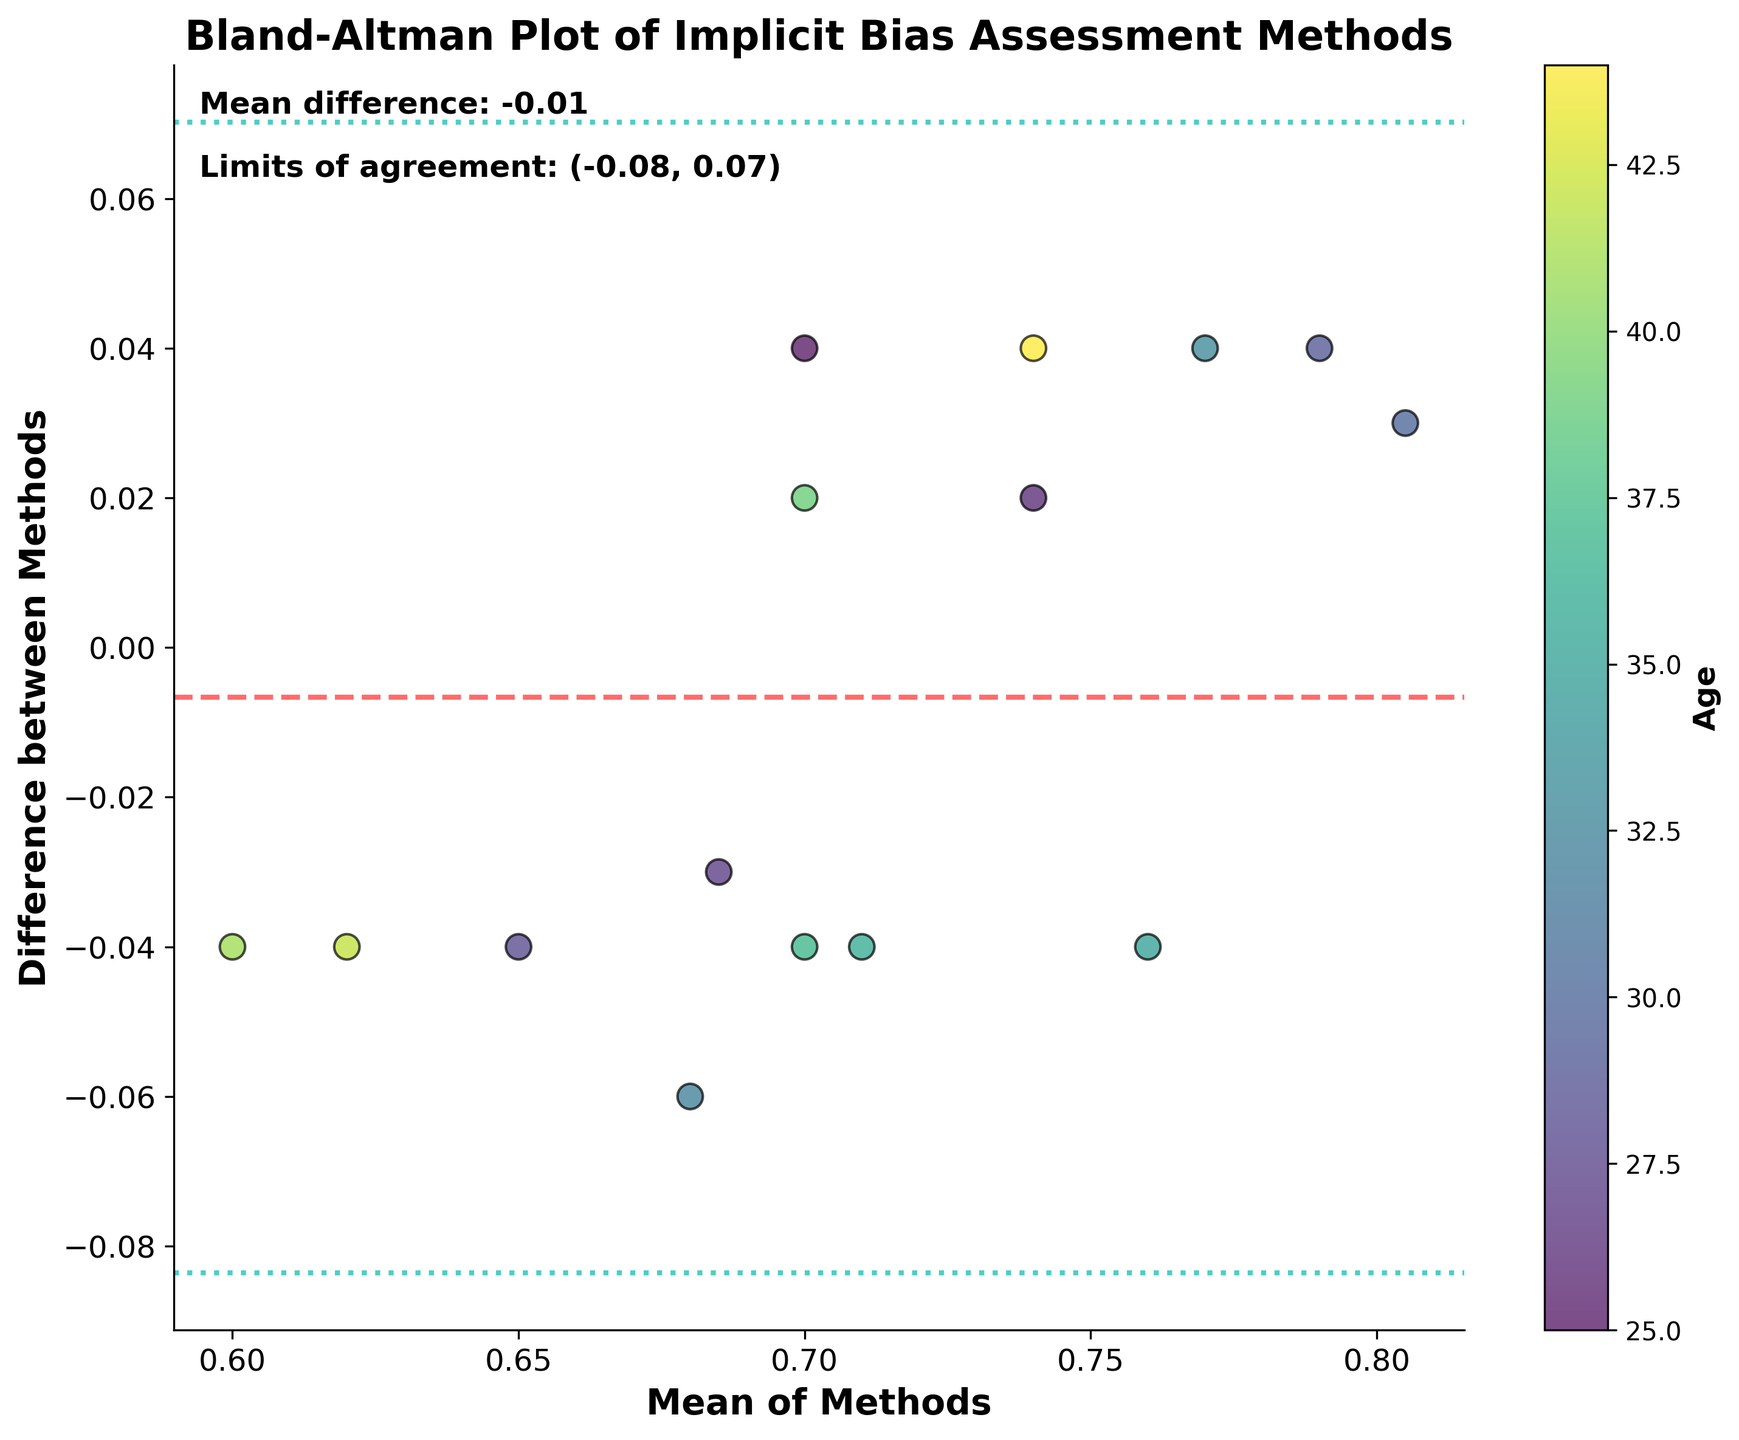What is the title of the plot? The plot's title is found at the top of the figure. It reads "Bland-Altman Plot of Implicit Bias Assessment Methods."
Answer: Bland-Altman Plot of Implicit Bias Assessment Methods How are the dots colored, and what does the color represent? The dots are colored in shades of green to yellow, representing different ages of the participants according to the color bar on the side.
Answer: Different ages What are the axes labeled? The axes labels are written next to each axis. The x-axis is labeled "Mean of Methods," and the y-axis is labeled "Difference between Methods."
Answer: Mean of Methods (x-axis), Difference between Methods (y-axis) What's the mean difference between the two methods? The mean difference is provided in the text at the top-left area of the plot. It is 0.02.
Answer: 0.02 What are the limits of agreement? The limits of agreement are indicated by the two dotted lines and are also mentioned in the top-left area of the plot. The limits are (-0.07, 0.11).
Answer: (-0.07, 0.11) Which age group shows the highest frequency of data points? By observing the color distribution of the dots, you can see that the age range that appears most frequently corresponds to the color in the middle of the color bar (approximately 30-35 years).
Answer: 30-35 years Are there any data points that lie outside the limits of agreement? By closely inspecting the plot, we can see where the dotted lines are drawn (-0.07 to 0.11). No point falls outside these lines, hence no data points lie outside the limits of agreement.
Answer: No Is there any noticeable pattern in the difference between methods based on participant age? By looking at the plot, we consider whether differences (y-axis) show any trend or pattern related to the colors representing age. There is no obvious pattern or trend related to age, as the colors are scattered randomly along the y-axis.
Answer: No clear pattern Which method appears to produce generally higher values based on the mean difference? The mean difference of 0.02 suggests that Method 1 generally produces higher values than Method 2. This is inferred by the positive mean difference (Method1 - Method2).
Answer: Method 1 How evenly distributed are the data points around the mean difference? By examining the scatter plot, we see that the data points are relatively well-distributed around the mean difference line (0.02), indicating a fairly consistent relationship between the two methods.
Answer: Fairly evenly distributed 